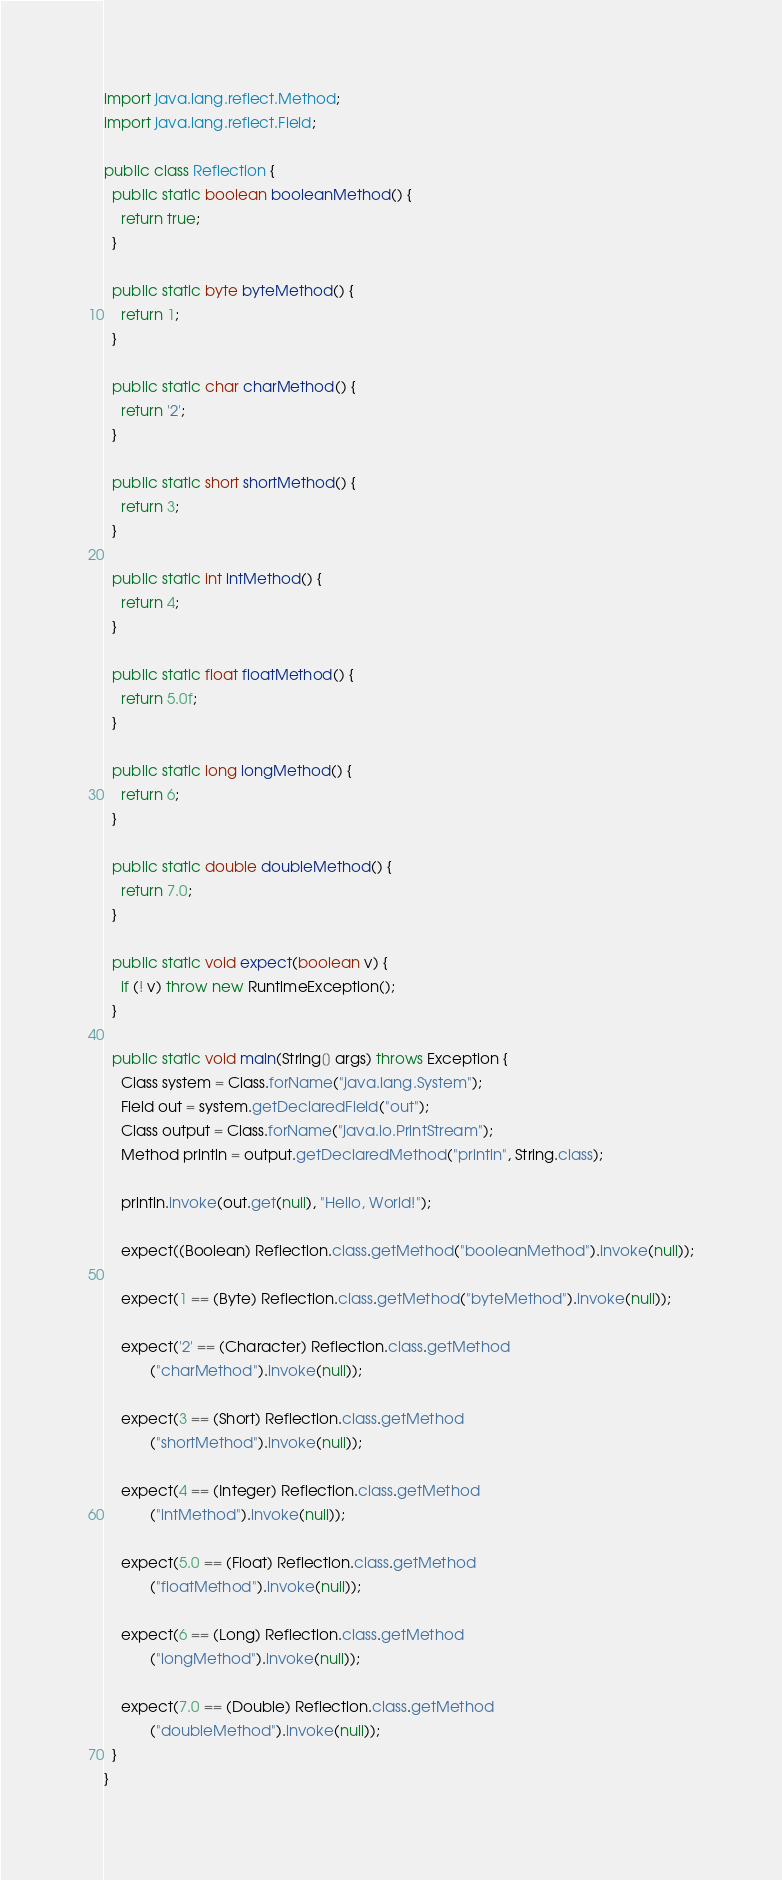<code> <loc_0><loc_0><loc_500><loc_500><_Java_>import java.lang.reflect.Method;
import java.lang.reflect.Field;

public class Reflection {
  public static boolean booleanMethod() {
    return true;
  }

  public static byte byteMethod() {
    return 1;
  }

  public static char charMethod() {
    return '2';
  }

  public static short shortMethod() {
    return 3;
  }

  public static int intMethod() {
    return 4;
  }

  public static float floatMethod() {
    return 5.0f;
  }

  public static long longMethod() {
    return 6;
  }

  public static double doubleMethod() {
    return 7.0;
  }

  public static void expect(boolean v) {
    if (! v) throw new RuntimeException();
  }

  public static void main(String[] args) throws Exception {
    Class system = Class.forName("java.lang.System");
    Field out = system.getDeclaredField("out");
    Class output = Class.forName("java.io.PrintStream");
    Method println = output.getDeclaredMethod("println", String.class);

    println.invoke(out.get(null), "Hello, World!");

    expect((Boolean) Reflection.class.getMethod("booleanMethod").invoke(null));

    expect(1 == (Byte) Reflection.class.getMethod("byteMethod").invoke(null));

    expect('2' == (Character) Reflection.class.getMethod
           ("charMethod").invoke(null));

    expect(3 == (Short) Reflection.class.getMethod
           ("shortMethod").invoke(null));

    expect(4 == (Integer) Reflection.class.getMethod
           ("intMethod").invoke(null));

    expect(5.0 == (Float) Reflection.class.getMethod
           ("floatMethod").invoke(null));

    expect(6 == (Long) Reflection.class.getMethod
           ("longMethod").invoke(null));

    expect(7.0 == (Double) Reflection.class.getMethod
           ("doubleMethod").invoke(null));
  }
}
</code> 